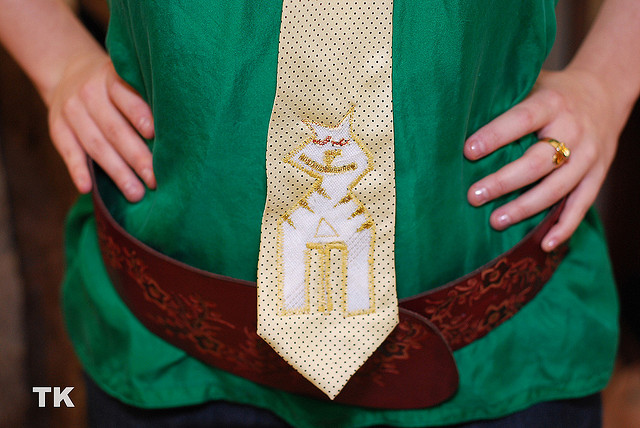Please extract the text content from this image. TK 